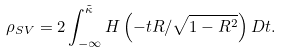Convert formula to latex. <formula><loc_0><loc_0><loc_500><loc_500>\rho _ { S V } = 2 \int _ { - \infty } ^ { \tilde { \kappa } } H \left ( - t R / \sqrt { 1 - R ^ { 2 } } \right ) D t .</formula> 